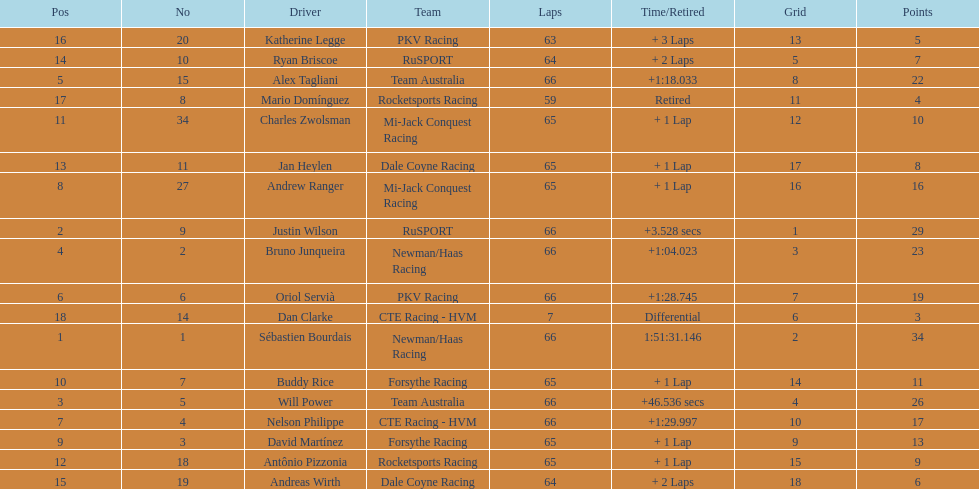Who are the drivers? Sébastien Bourdais, Justin Wilson, Will Power, Bruno Junqueira, Alex Tagliani, Oriol Servià, Nelson Philippe, Andrew Ranger, David Martínez, Buddy Rice, Charles Zwolsman, Antônio Pizzonia, Jan Heylen, Ryan Briscoe, Andreas Wirth, Katherine Legge, Mario Domínguez, Dan Clarke. What are their numbers? 1, 9, 5, 2, 15, 6, 4, 27, 3, 7, 34, 18, 11, 10, 19, 20, 8, 14. What are their positions? 1, 2, 3, 4, 5, 6, 7, 8, 9, 10, 11, 12, 13, 14, 15, 16, 17, 18. Which driver has the same number and position? Sébastien Bourdais. 